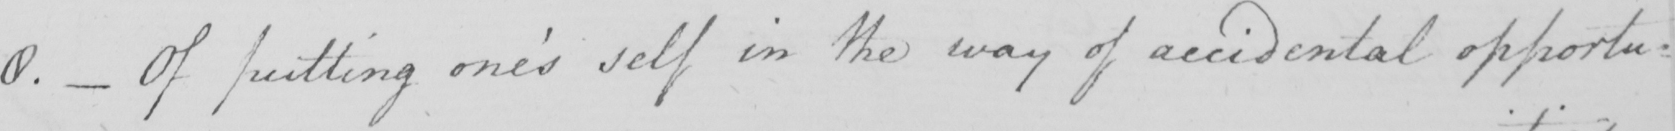Please transcribe the handwritten text in this image. 8 .  _  Of putting one ' s self in the way of accidental opportu-= 